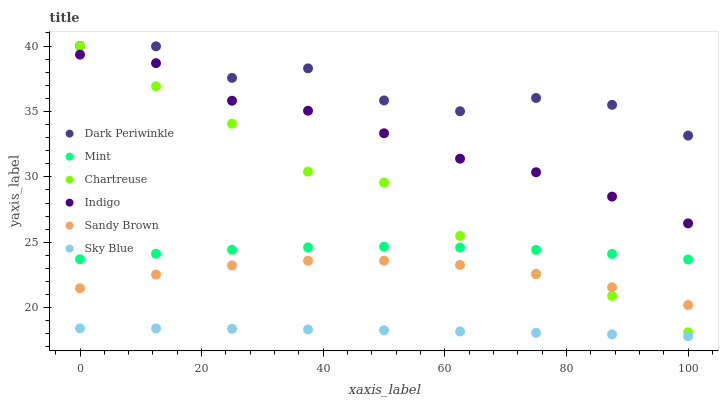Does Sky Blue have the minimum area under the curve?
Answer yes or no. Yes. Does Dark Periwinkle have the maximum area under the curve?
Answer yes or no. Yes. Does Sandy Brown have the minimum area under the curve?
Answer yes or no. No. Does Sandy Brown have the maximum area under the curve?
Answer yes or no. No. Is Sky Blue the smoothest?
Answer yes or no. Yes. Is Dark Periwinkle the roughest?
Answer yes or no. Yes. Is Sandy Brown the smoothest?
Answer yes or no. No. Is Sandy Brown the roughest?
Answer yes or no. No. Does Sky Blue have the lowest value?
Answer yes or no. Yes. Does Sandy Brown have the lowest value?
Answer yes or no. No. Does Dark Periwinkle have the highest value?
Answer yes or no. Yes. Does Sandy Brown have the highest value?
Answer yes or no. No. Is Sky Blue less than Chartreuse?
Answer yes or no. Yes. Is Mint greater than Sandy Brown?
Answer yes or no. Yes. Does Indigo intersect Chartreuse?
Answer yes or no. Yes. Is Indigo less than Chartreuse?
Answer yes or no. No. Is Indigo greater than Chartreuse?
Answer yes or no. No. Does Sky Blue intersect Chartreuse?
Answer yes or no. No. 